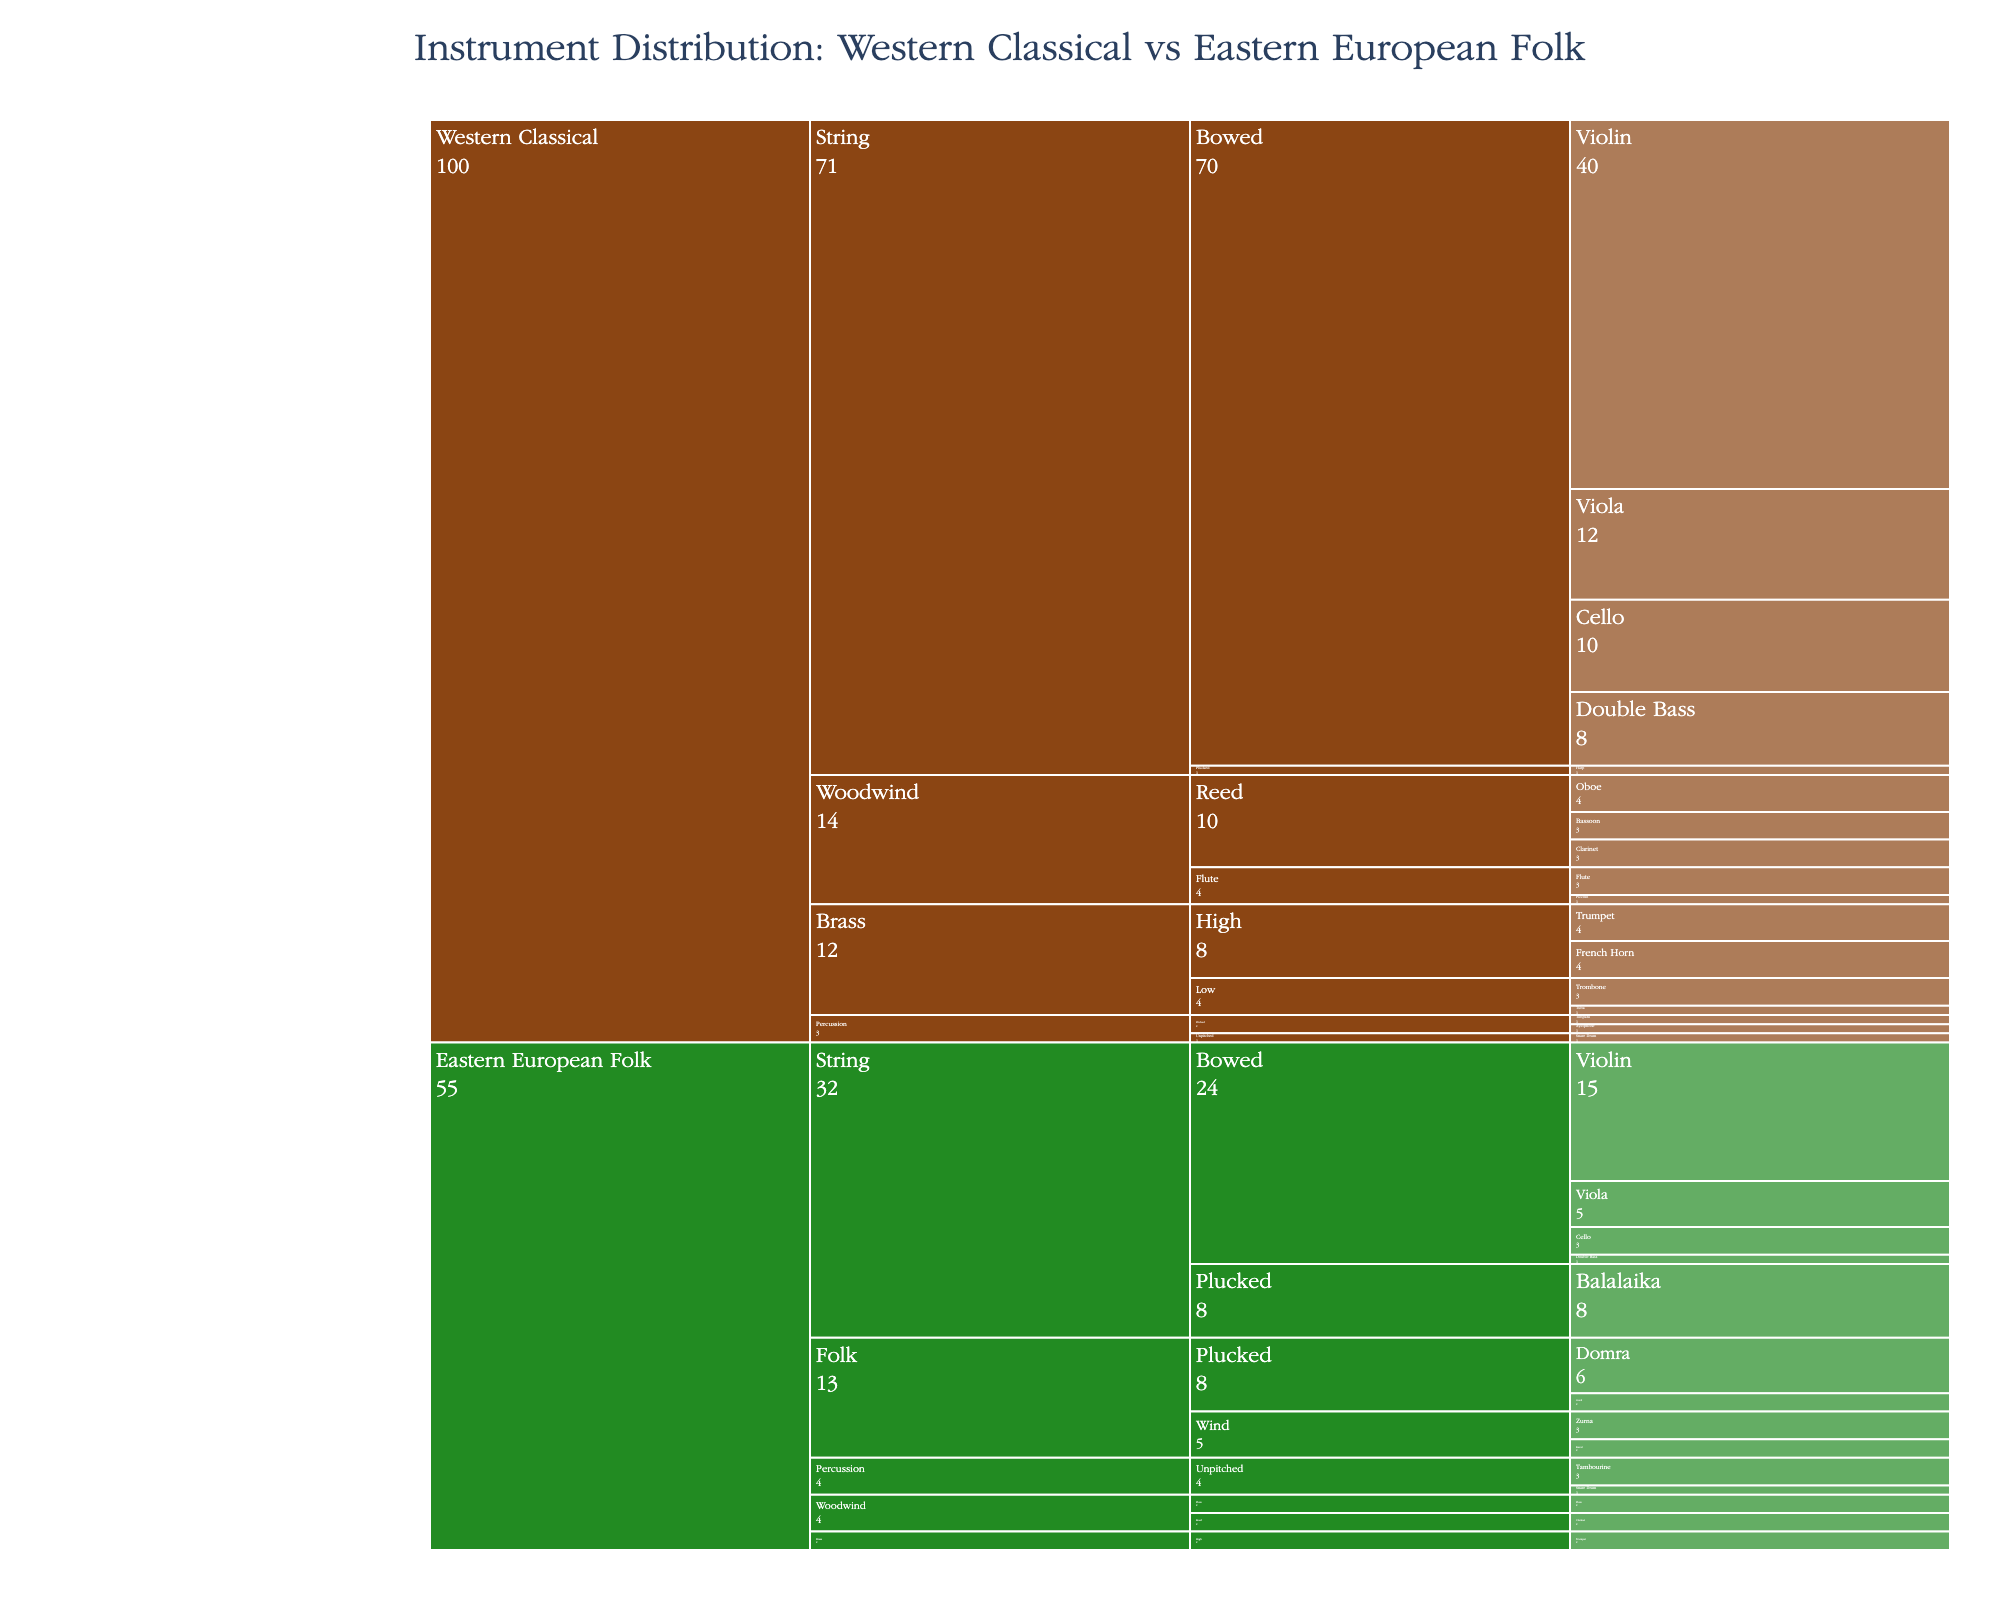What's the total number of Violin players in Western Classical orchestras? To find the number of Violin players in Western Classical orchestras, reference the count next to "Violin" under "String > Bowed" in the "Western Classical" section.
Answer: 40 How many more Cellos are there in Western Classical orchestras compared to Eastern European folk ensembles? Find the counts for Cellos under "String > Bowed" for both "Western Classical" and "Eastern European Folk", then subtract the two: 10 (Western Classical) - 3 (Eastern European Folk).
Answer: 7 Which ensemble has a higher count of plucked string instruments? Sum up the counts of plucked string instruments in both ensembles. For Western Classical: Violin (0), Viola (0), Cello (0), Harp (1). For Eastern European Folk: Balalaika (8), Domra (6), Gusli (2). Compare the sums: Western Classical (1) vs. Eastern European Folk (16).
Answer: Eastern European Folk What is the total number of percussion instruments in Eastern European folk ensembles? Add the counts of all percussion instruments under "Percussion" in Eastern European Folk: Snare Drum (1) + Tambourine (3).
Answer: 4 What is the difference in the number of Double Bass players between Western Classical and Eastern European folk ensembles? Look for the Double Bass counts under "String > Bowed" for both ensembles and find their difference: 8 (Western Classical) - 1 (Eastern European Folk).
Answer: 7 Which instrument appears only in the Eastern European folk ensembles and not in Western Classical orchestras? Look through the instrument list under both ensembles and identify the instruments exclusive to Eastern European Folk: Balalaika, Domra, Gusli, Zurna, Kaval.
Answer: Multiple (Balalaika, Domra, Gusli, Zurna, Kaval) What is the total number of bowed string instruments across both ensembles? Sum the counts of all bowed string instruments in both ensembles: Western Classical: Violin (40) + Viola (12) + Cello (10) + Double Bass (8) = 70, Eastern European Folk: Violin (15) + Viola (5) + Cello (3) + Double Bass (1) = 24, then add these two sums together: 70 + 24.
Answer: 94 Which category has the most significant difference in total instrument count between the two ensembles? First, find the total counts for each category in both ensembles and then calculate the differences:
"String": Western Classical (40+12+10+8+1) - Eastern European Folk (15+5+3+1+8+6+2) = 71 - 40 = 31
"Woodwind": Western Classical (4+3+3+3+1) - Eastern European Folk (0+2+2+3+2) = 14 - 9 = 5
"Brass": Western Classical (4+4+3+1) - Eastern European Folk (2) = 12 - 2 = 10
"Percussion": Western Classical (1+1+1) - Eastern European Folk (1+3) = 3 - 4 = -1
"Folk Instruments": Western Classical (0) - Eastern European Folk (8+6+2+3+2) = 0 - 21 = -21. The "String" category has the largest difference.
Answer: String What is the proportion of folk instruments in Eastern European folk ensembles compared to the total number of instruments in Eastern European folk ensembles? Calculate the proportion of folk instruments in the total count for Eastern European folk ensembles. 
Folk instruments: Balalaika (8) + Domra (6) + Gusli (2) + Zurna (3) + Kaval (2) = 21. Total number of instruments = 52.
Proportion: 21 / 52.
Answer: 21/52 or approximately 0.40 